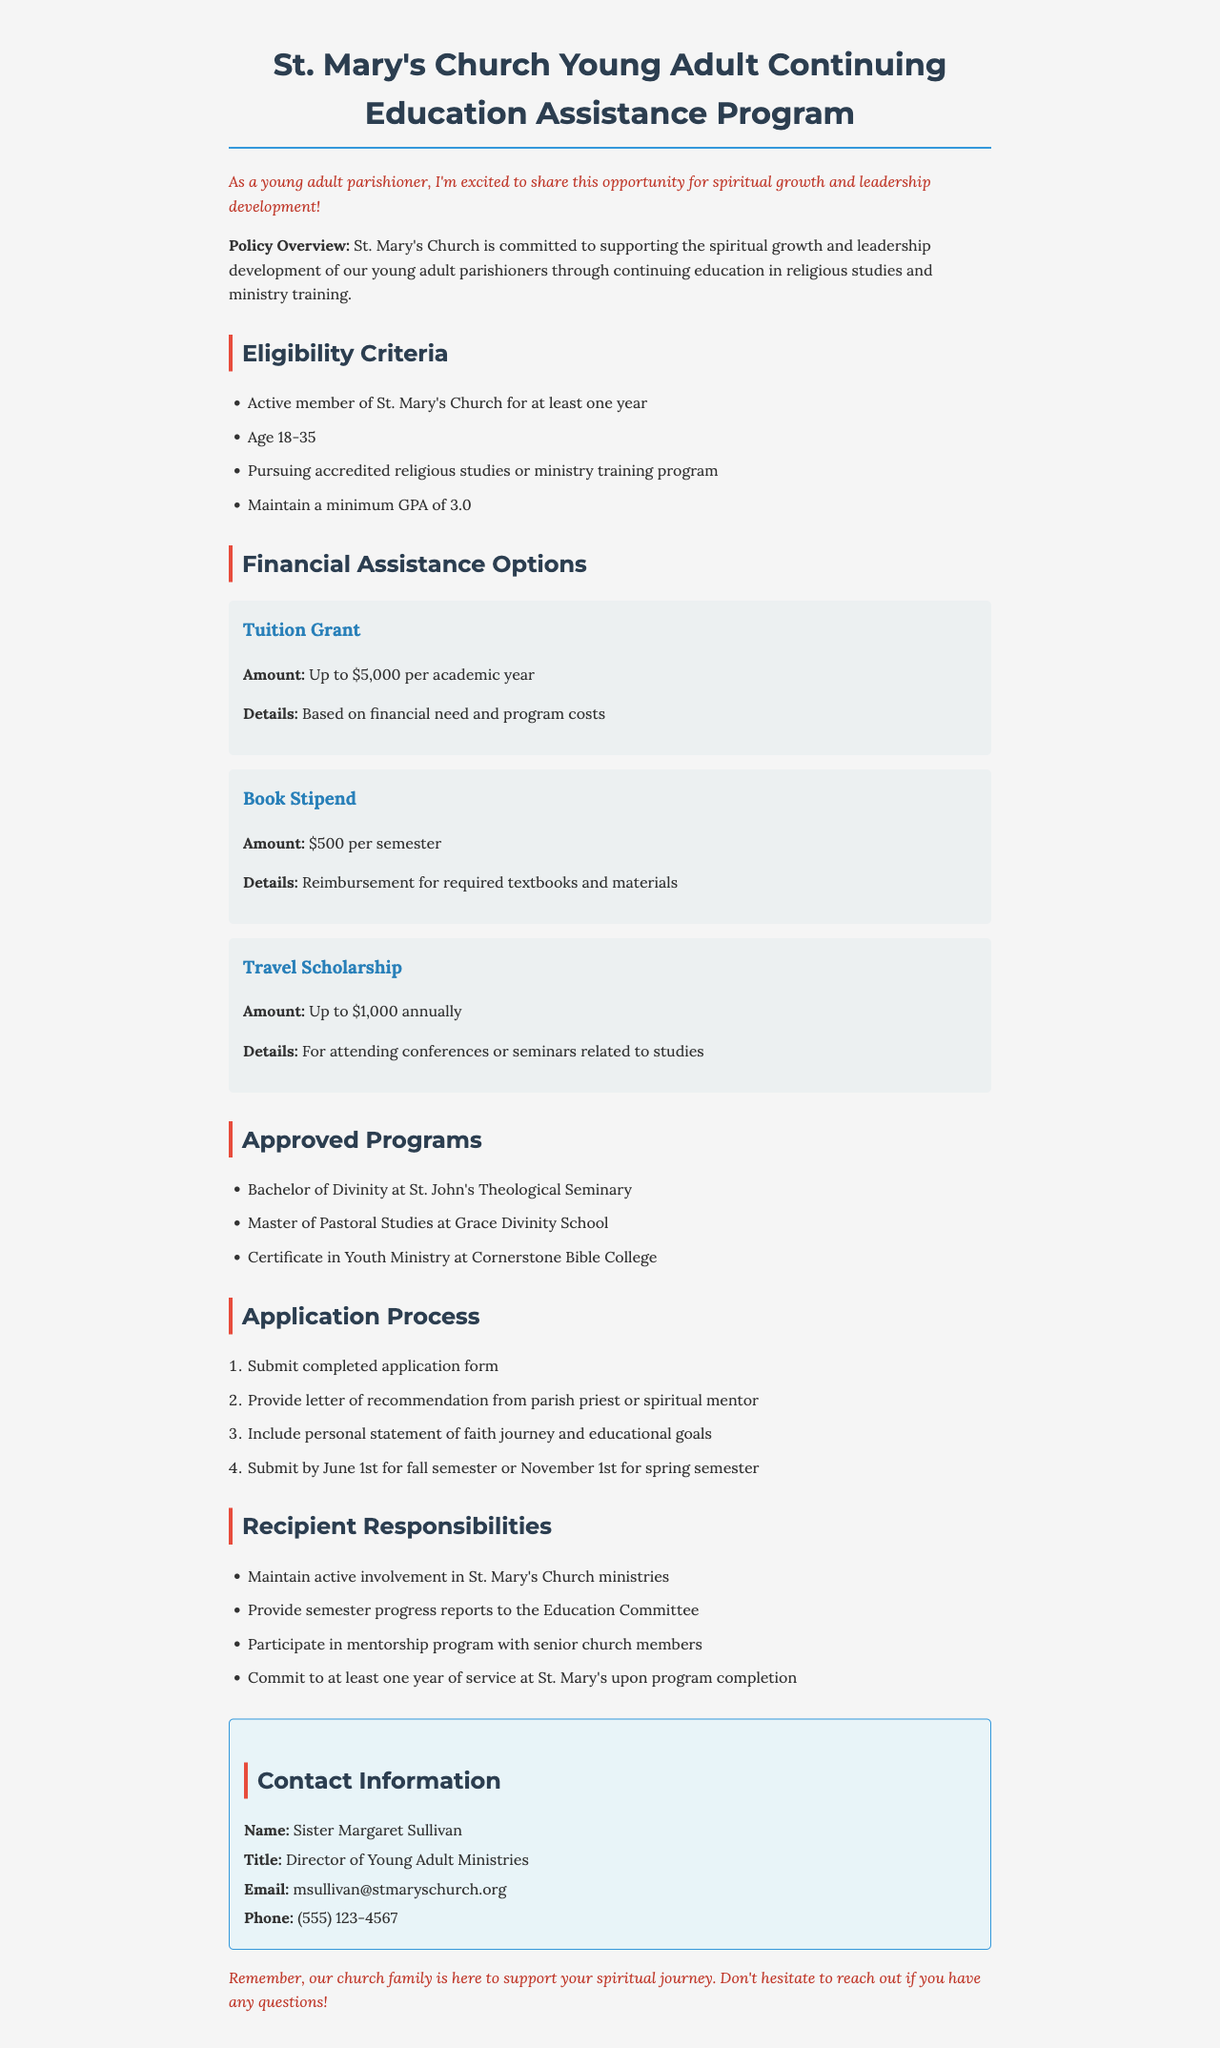What is the maximum Tuition Grant amount? The Tuition Grant can provide financial assistance for educational purposes, with a maximum of $5,000 per academic year stated in the financial assistance options.
Answer: Up to $5,000 What is the age range for eligibility? The eligibility criteria specify that applicants must be between the ages of 18 and 35 to qualify for the program.
Answer: 18-35 How much is the Book Stipend? The document states that the Book Stipend provides reimbursement for required textbooks and materials, with a specific amount of $500 per semester.
Answer: $500 per semester Who is the contact person for this program? The contact person is identified as Sister Margaret Sullivan, who is the Director of Young Adult Ministries, providing a specific point of contact for inquiries.
Answer: Sister Margaret Sullivan What is the deadline for the fall semester application? The application process outlines that completed applications must be submitted by June 1st for the fall semester, indicating a specific timeframe for applicants.
Answer: June 1st What is a requirement for recipients of financial assistance? One of the recipient responsibilities outlined in the document is to maintain active involvement in St. Mary's Church ministries.
Answer: Maintain active involvement in St. Mary's Church ministries Which program requires a personal statement? The application process includes several steps, one of which requires the submission of a personal statement outlining the candidate's faith journey and educational goals.
Answer: Personal statement of faith journey and educational goals How many approved programs are listed? The section on approved programs details three specific programs available for financial assistance, indicating options for further education and training.
Answer: Three 